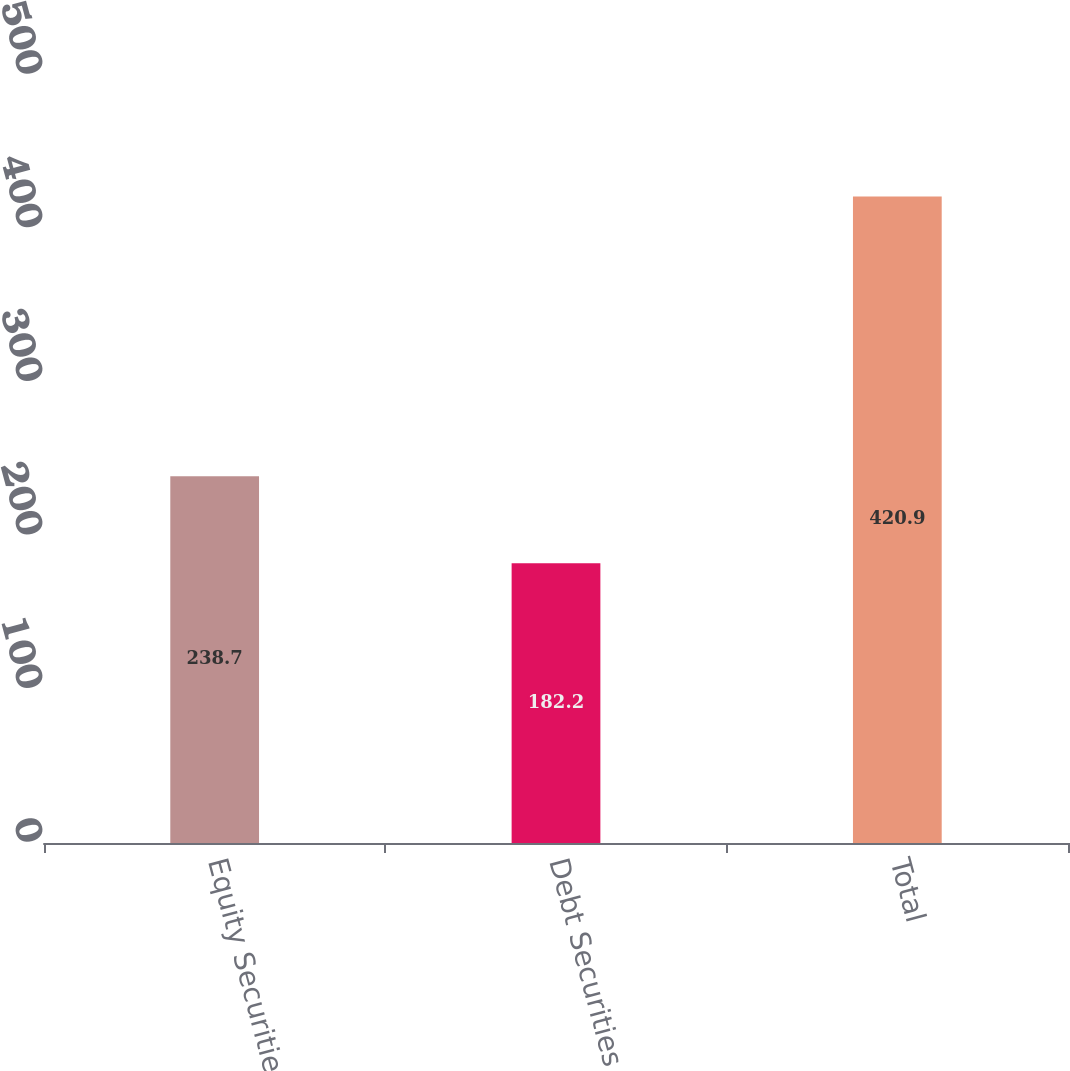Convert chart to OTSL. <chart><loc_0><loc_0><loc_500><loc_500><bar_chart><fcel>Equity Securities<fcel>Debt Securities<fcel>Total<nl><fcel>238.7<fcel>182.2<fcel>420.9<nl></chart> 